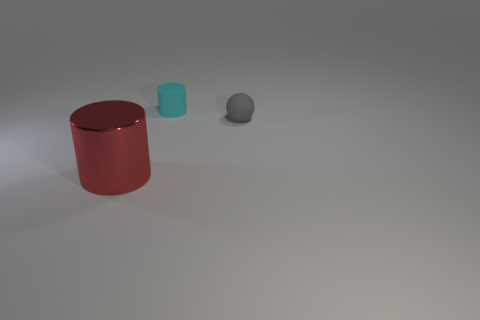Are the tiny cylinder and the cylinder that is in front of the gray ball made of the same material?
Your answer should be compact. No. What number of metal objects are large red cylinders or things?
Make the answer very short. 1. There is a cylinder that is behind the red cylinder; how big is it?
Your answer should be very brief. Small. There is a cyan thing that is the same material as the gray thing; what size is it?
Provide a succinct answer. Small. What number of matte cylinders have the same color as the small ball?
Make the answer very short. 0. Are there any small brown matte spheres?
Provide a succinct answer. No. There is a red shiny thing; is its shape the same as the rubber thing behind the gray object?
Provide a succinct answer. Yes. What color is the cylinder that is on the left side of the matte thing on the left side of the matte object that is right of the cyan rubber object?
Provide a succinct answer. Red. Are there any gray rubber objects in front of the gray matte ball?
Your response must be concise. No. Are there any big gray cylinders that have the same material as the red object?
Ensure brevity in your answer.  No. 